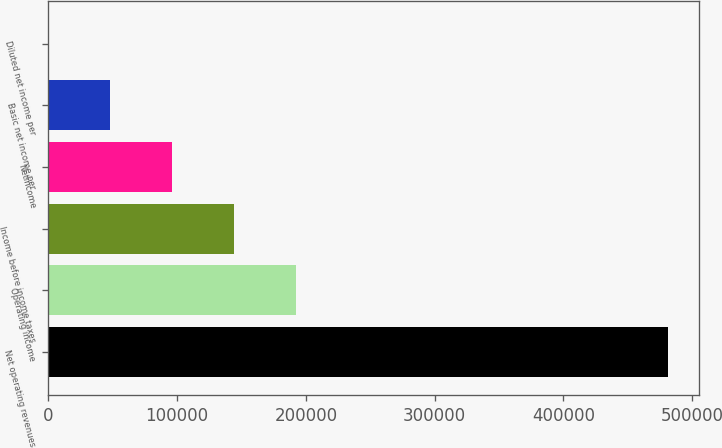<chart> <loc_0><loc_0><loc_500><loc_500><bar_chart><fcel>Net operating revenues<fcel>Operating income<fcel>Income before income taxes<fcel>Netincome<fcel>Basic net income per<fcel>Diluted net income per<nl><fcel>481194<fcel>192478<fcel>144359<fcel>96239.4<fcel>48120.1<fcel>0.72<nl></chart> 